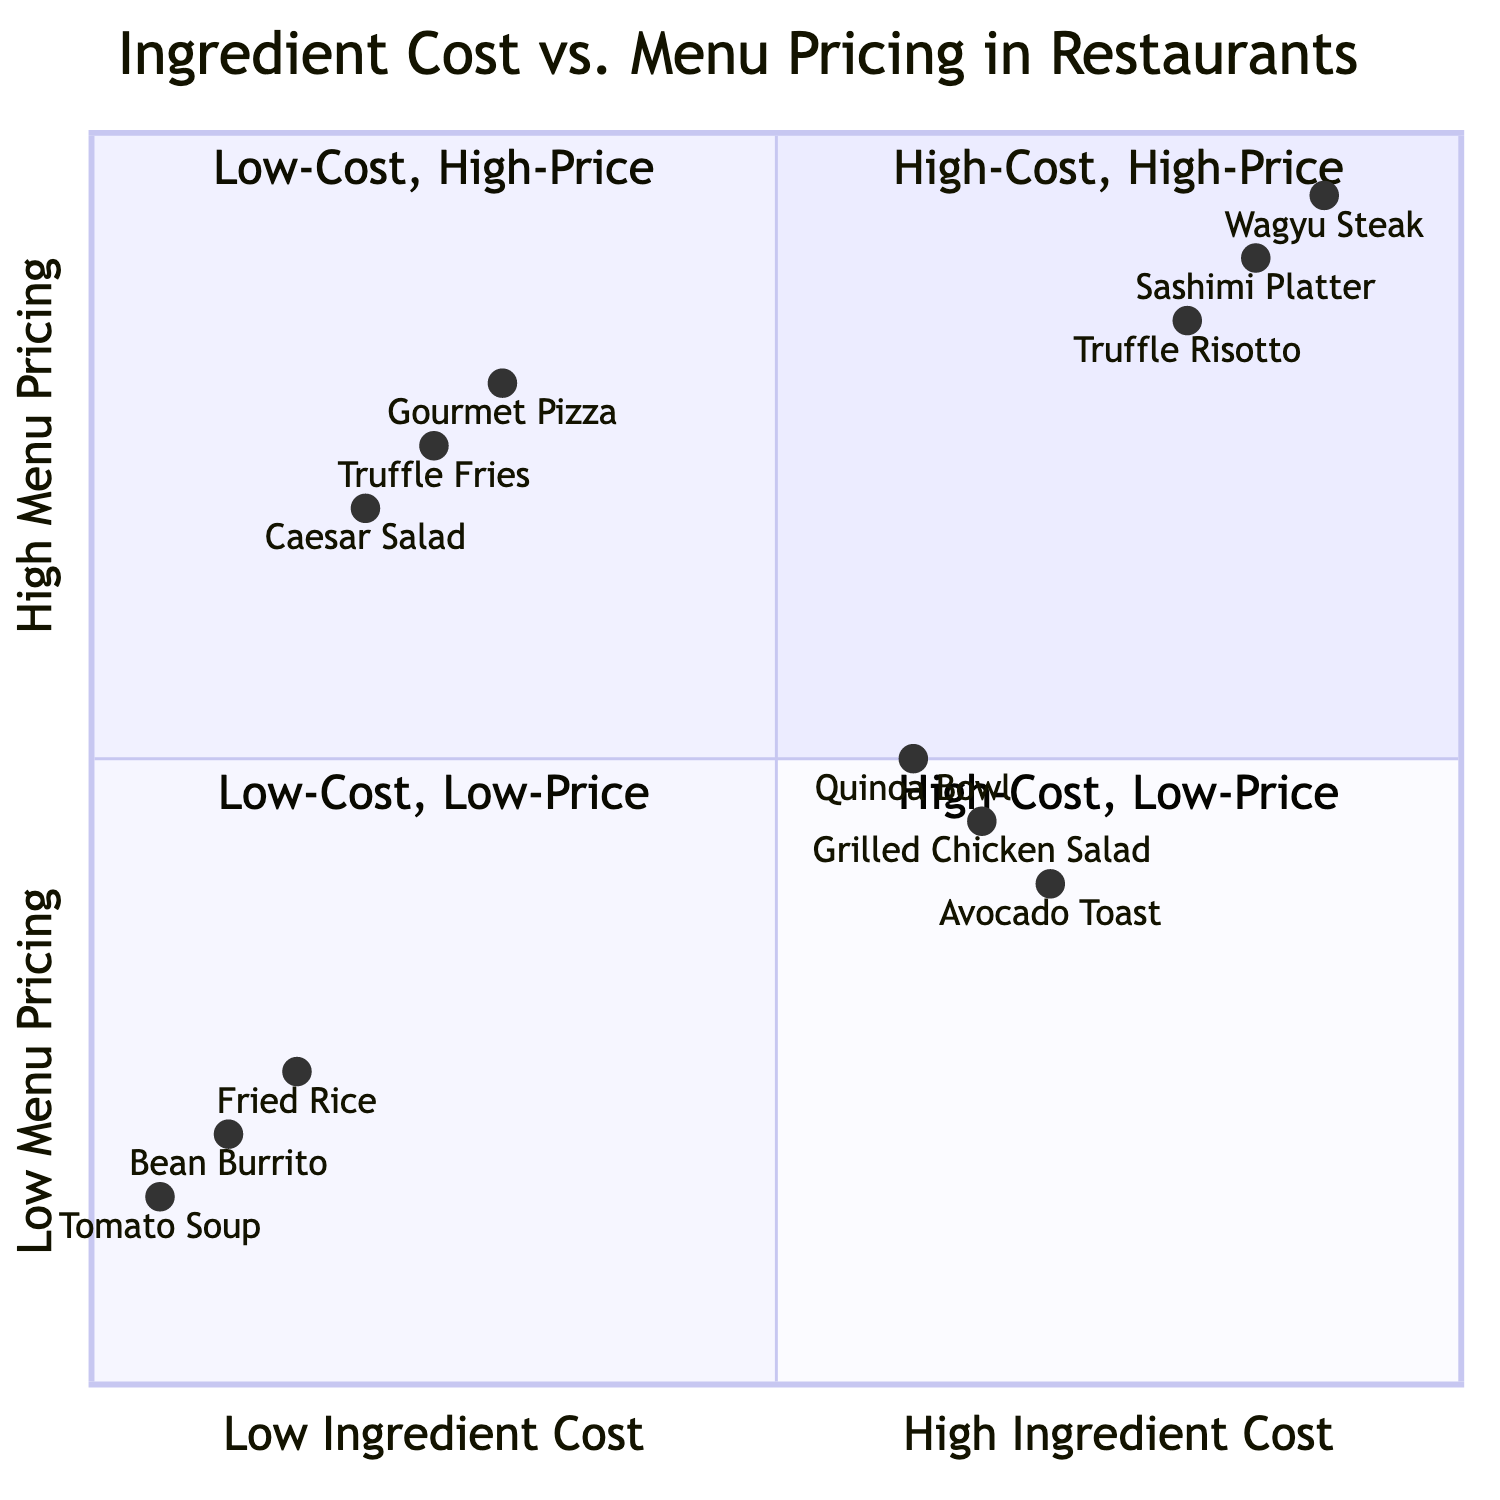What are the three menu items listed in the High-Cost Ingredients & High Menu Pricing quadrant? The High-Cost Ingredients & High Menu Pricing quadrant includes three specific examples of menu items: Wagyu Steak, Sashimi Platter, and Truffle Risotto. These items are directly mentioned in the quadrant description.
Answer: Wagyu Steak, Sashimi Platter, Truffle Risotto Which ingredient is paired with Grilled Chicken Salad? The ingredient for Grilled Chicken Salad, which is located in the High-Cost Ingredients & Low Menu Pricing quadrant, is Free-Range Chicken. This information is explicitly provided in the description of that quadrant.
Answer: Free-Range Chicken How many customer purchasing patterns are associated with Low-Cost Ingredients & Low Menu Pricing? The quadrant for Low-Cost Ingredients & Low Menu Pricing has three specified customer purchasing patterns: students, frequent dining, and family dining. The total number of patterns can be counted from the quadrant information.
Answer: Three In which quadrant would you find Organic Avocado? Organic Avocado is listed in the High-Cost Ingredients & Low Menu Pricing quadrant. As per the quadrant definitions, the ingredient is specifically mentioned alongside certain menu items and customer patterns in that section.
Answer: High-Cost Ingredients & Low Menu Pricing What is the customer purchasing pattern for the dish that uses Black Winter Truffle? The purchasing pattern for the dish using Black Winter Truffle, which is in the High-Cost Ingredients & High Menu Pricing quadrant, emphasizes high-income and special occasions, as defined in the customer pattern descriptions of that quadrant.
Answer: High income, special occasions Which menu item represents the lowest cost ingredient on the chart? The menu item Tomato Soup, which utilizes the lowest cost ingredient (Tomato) in the Low-Cost Ingredients & Low Menu Pricing quadrant, illustrates this category in the chart. Thus, it is recognized as the lowest cost ingredient representation.
Answer: Tomato Soup What factors contribute to customer patterns in the Low-Cost Ingredients & High Menu Pricing quadrant? The customer purchasing patterns in the Low-Cost Ingredients & High Menu Pricing quadrant are influenced by factors such as tourists, trust in brand, and luxury perception, all of which are explicitly listed in the quadrant description.
Answer: Tourists, trust in brand, luxury perception How does the pricing strategy appear in the quadrant with Quinoa Bowl? The Quinoa Bowl is placed in the High-Cost Ingredients & Low Menu Pricing quadrant, where the menu pricing is low compared to the ingredient cost, indicating a pricing strategy aimed at health-conscious consumers who seek value without high expense.
Answer: High-Cost Ingredients & Low Menu Pricing Which quadrant contains Flour as an ingredient? Flour is categorized in the Low-Cost Ingredients & High Menu Pricing quadrant, which highlights the use of lower-cost ingredients in dishes that are priced higher, such as Gourmet Pizza. This distinction allows us to locate it accurately.
Answer: Low-Cost Ingredients & High Menu Pricing 